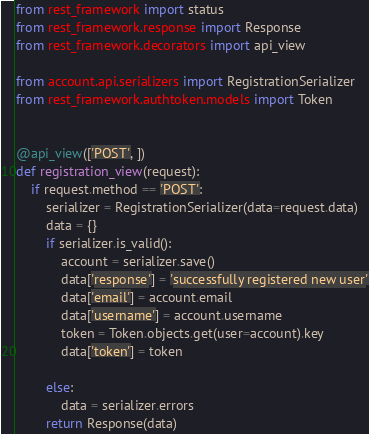<code> <loc_0><loc_0><loc_500><loc_500><_Python_>from rest_framework import status
from rest_framework.response import Response
from rest_framework.decorators import api_view

from account.api.serializers import RegistrationSerializer
from rest_framework.authtoken.models import Token


@api_view(['POST', ])
def registration_view(request):
    if request.method == 'POST':
        serializer = RegistrationSerializer(data=request.data)
        data = {}
        if serializer.is_valid():
            account = serializer.save()
            data['response'] = 'successfully registered new user'
            data['email'] = account.email
            data['username'] = account.username
            token = Token.objects.get(user=account).key
            data['token'] = token

        else:
            data = serializer.errors
        return Response(data)

</code> 